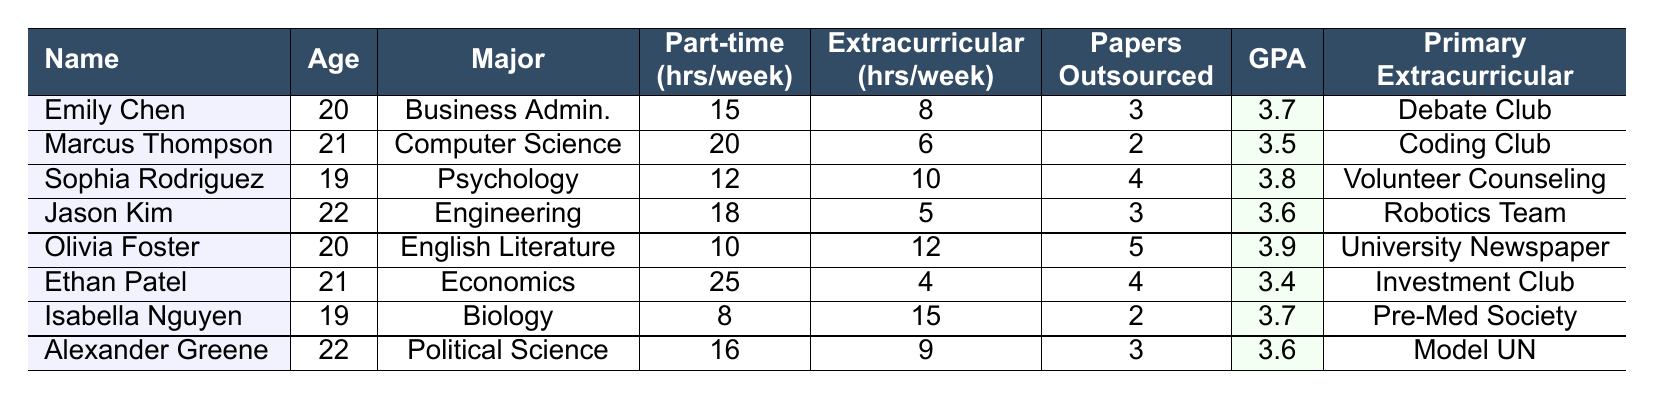What is the GPA of Sophia Rodriguez? To find Sophia Rodriguez's GPA, we look at her information in the table. She is listed with a GPA of 3.8.
Answer: 3.8 How many hours per week does Ethan Patel work at his part-time job? The table provides Ethan Patel's hours per week at his part-time job, which is listed as 25 hours.
Answer: 25 Which student has the highest hours allocated to extracurricular activities? By comparing the hours per week for extracurricular activities among all students, Isabella Nguyen has the highest at 15 hours.
Answer: Isabella Nguyen How many total hours per week does Olivia Foster allocate for both her part-time job and extracurricular activities? Olivia Foster works 10 hours per week at her part-time job and spends 12 hours on extracurricular activities, making the total 10 + 12 = 22 hours.
Answer: 22 What is the average GPA of all the students in the table? First, we add the GPAs: 3.7 + 3.5 + 3.8 + 3.6 + 3.9 + 3.4 + 3.7 + 3.6 = 27.2. There are 8 students, so the average is 27.2 / 8 = 3.4.
Answer: 3.4 Does Alexander Greene outsource more or less than three papers per semester? Alexander Greene outsources 3 papers per semester, which is equal to three. Hence, it is neither more nor less.
Answer: No Which student has the least hours committed to extracurricular activities? By reviewing the extracurricular hours, Ethan Patel has the least at 4 hours per week.
Answer: Ethan Patel If we consider only part-time jobs that are more than 15 hours per week, how many students meet this criterion? The students who work more than 15 hours per week are Marcus Thompson (20), Ethan Patel (25), and Jason Kim (18). That gives us a total of 3 students.
Answer: 3 What is the difference in hours per week between the student working the most and the student working the least at their part-time job? The highest is Ethan Patel with 25 hours, and the lowest is Isabella Nguyen with 8 hours. The difference is 25 - 8 = 17 hours.
Answer: 17 Which student has the best GPA and what is their primary extracurricular activity? Olivia Foster has the highest GPA of 3.9 and her primary extracurricular activity is the University Newspaper.
Answer: Olivia Foster; University Newspaper Which major is most represented among students who outsource papers? Looking at the table, each major has at least one student, but the most papers outsourced are from those in English Literature, Economics, and Psychology. This means no singular major dominates outsourcing.
Answer: No dominant major 